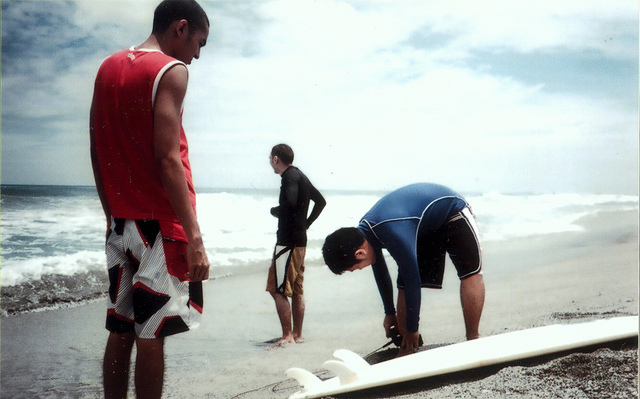What does the environment suggest about the location? The beach setting with sandy shores and waves breaking in the background suggests a coastal location suitable for surfing. The sky appears partly cloudy, indicating it might be early morning or late afternoon, which are popular times for surfers seeking favorable wind conditions. The attire of the individuals points towards a temperate climate, suitable for water activities. 